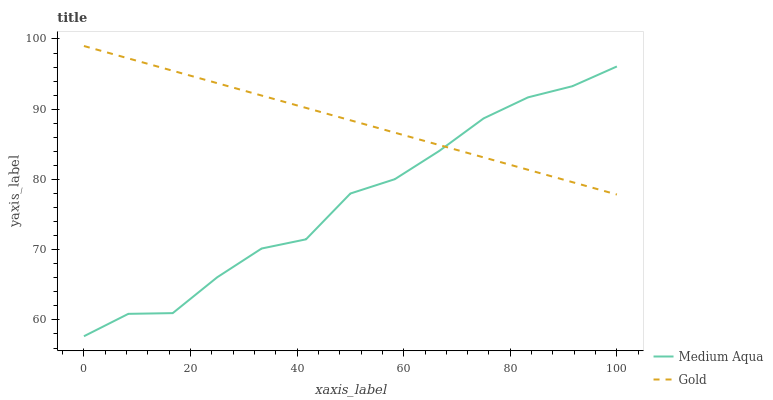Does Medium Aqua have the minimum area under the curve?
Answer yes or no. Yes. Does Gold have the maximum area under the curve?
Answer yes or no. Yes. Does Gold have the minimum area under the curve?
Answer yes or no. No. Is Gold the smoothest?
Answer yes or no. Yes. Is Medium Aqua the roughest?
Answer yes or no. Yes. Is Gold the roughest?
Answer yes or no. No. Does Medium Aqua have the lowest value?
Answer yes or no. Yes. Does Gold have the lowest value?
Answer yes or no. No. Does Gold have the highest value?
Answer yes or no. Yes. Does Gold intersect Medium Aqua?
Answer yes or no. Yes. Is Gold less than Medium Aqua?
Answer yes or no. No. Is Gold greater than Medium Aqua?
Answer yes or no. No. 